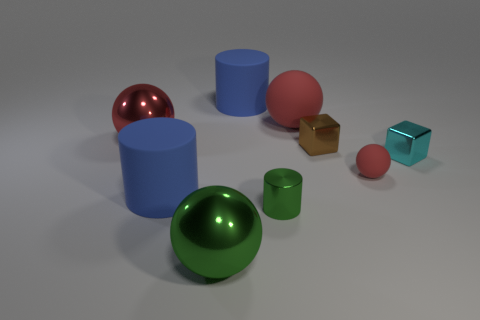How many red balls must be subtracted to get 1 red balls? 2 Subtract all blue cubes. How many red balls are left? 3 Add 1 small green cylinders. How many objects exist? 10 Subtract all balls. How many objects are left? 5 Add 9 tiny brown cubes. How many tiny brown cubes exist? 10 Subtract 1 green balls. How many objects are left? 8 Subtract all large red rubber spheres. Subtract all tiny red things. How many objects are left? 7 Add 4 metallic cylinders. How many metallic cylinders are left? 5 